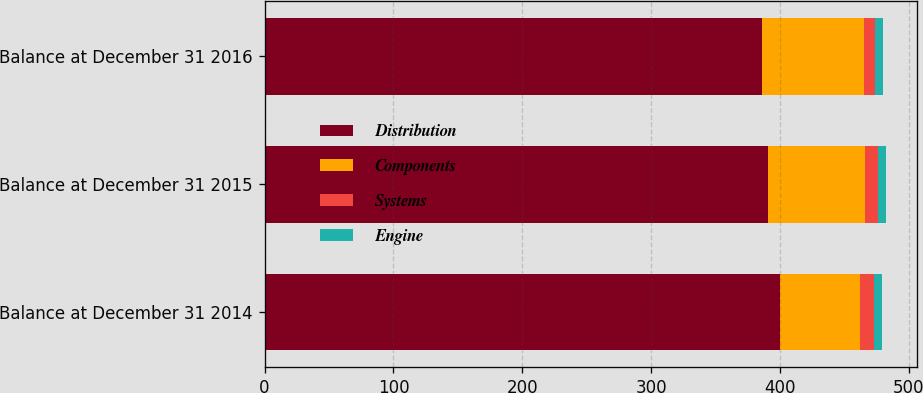<chart> <loc_0><loc_0><loc_500><loc_500><stacked_bar_chart><ecel><fcel>Balance at December 31 2014<fcel>Balance at December 31 2015<fcel>Balance at December 31 2016<nl><fcel>Distribution<fcel>400<fcel>391<fcel>386<nl><fcel>Components<fcel>62<fcel>75<fcel>79<nl><fcel>Systems<fcel>11<fcel>10<fcel>9<nl><fcel>Engine<fcel>6<fcel>6<fcel>6<nl></chart> 